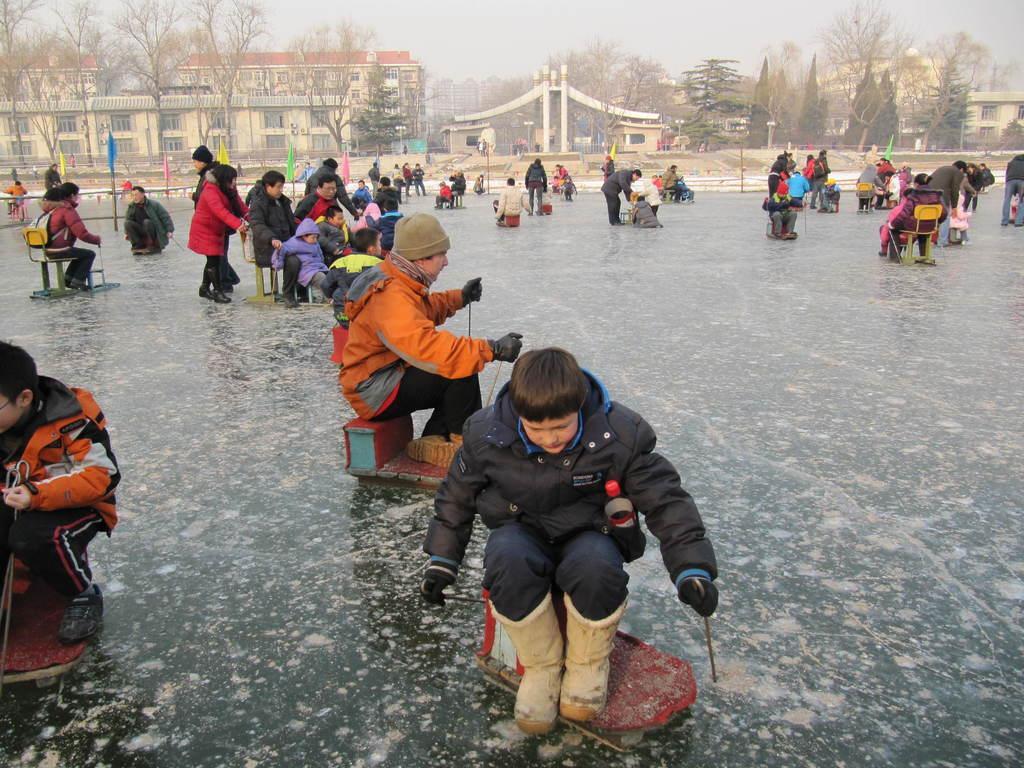In one or two sentences, can you explain what this image depicts? In the front of the image I can see few people are sitting on objects, holding sticks and doing ice skating. In the background of the image there are buildings, trees, flags, sky and objects. 